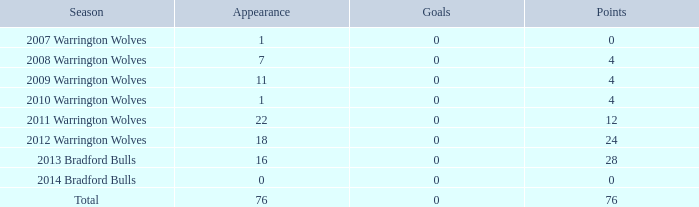What is the lowest appearance when goals is more than 0? None. 